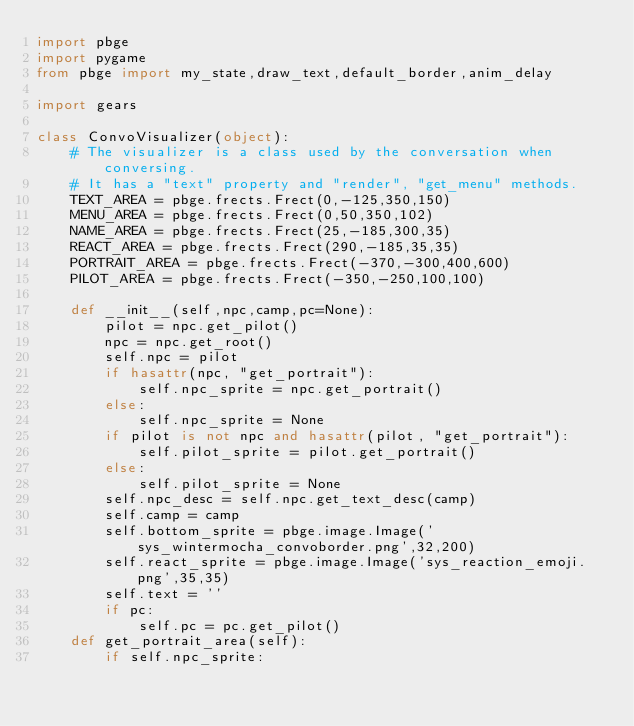Convert code to text. <code><loc_0><loc_0><loc_500><loc_500><_Python_>import pbge
import pygame
from pbge import my_state,draw_text,default_border,anim_delay

import gears

class ConvoVisualizer(object):
    # The visualizer is a class used by the conversation when conversing.
    # It has a "text" property and "render", "get_menu" methods.
    TEXT_AREA = pbge.frects.Frect(0,-125,350,150)
    MENU_AREA = pbge.frects.Frect(0,50,350,102)
    NAME_AREA = pbge.frects.Frect(25,-185,300,35)
    REACT_AREA = pbge.frects.Frect(290,-185,35,35)
    PORTRAIT_AREA = pbge.frects.Frect(-370,-300,400,600)
    PILOT_AREA = pbge.frects.Frect(-350,-250,100,100)
    
    def __init__(self,npc,camp,pc=None):
        pilot = npc.get_pilot()
        npc = npc.get_root()
        self.npc = pilot
        if hasattr(npc, "get_portrait"):
            self.npc_sprite = npc.get_portrait()
        else:
            self.npc_sprite = None
        if pilot is not npc and hasattr(pilot, "get_portrait"):
            self.pilot_sprite = pilot.get_portrait()
        else:
            self.pilot_sprite = None
        self.npc_desc = self.npc.get_text_desc(camp)
        self.camp = camp
        self.bottom_sprite = pbge.image.Image('sys_wintermocha_convoborder.png',32,200)
        self.react_sprite = pbge.image.Image('sys_reaction_emoji.png',35,35)
        self.text = ''
        if pc:
            self.pc = pc.get_pilot()
    def get_portrait_area(self):
        if self.npc_sprite:</code> 